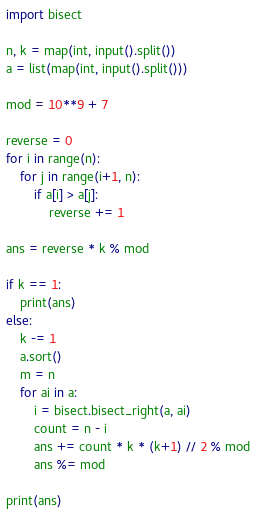Convert code to text. <code><loc_0><loc_0><loc_500><loc_500><_Python_>import bisect

n, k = map(int, input().split())
a = list(map(int, input().split()))

mod = 10**9 + 7

reverse = 0
for i in range(n):
    for j in range(i+1, n):
        if a[i] > a[j]:
            reverse += 1

ans = reverse * k % mod

if k == 1:
    print(ans)
else:
    k -= 1
    a.sort()
    m = n
    for ai in a:
        i = bisect.bisect_right(a, ai)
        count = n - i
        ans += count * k * (k+1) // 2 % mod
        ans %= mod

print(ans)

</code> 